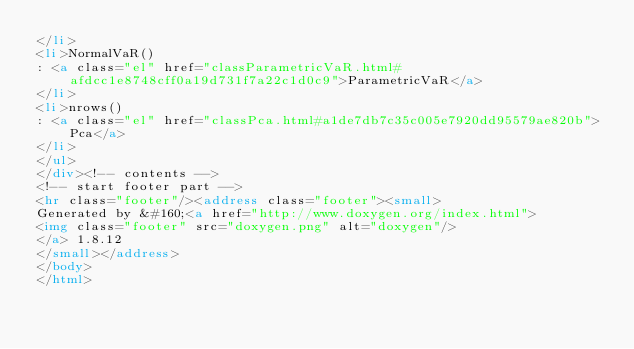<code> <loc_0><loc_0><loc_500><loc_500><_HTML_></li>
<li>NormalVaR()
: <a class="el" href="classParametricVaR.html#afdcc1e8748cff0a19d731f7a22c1d0c9">ParametricVaR</a>
</li>
<li>nrows()
: <a class="el" href="classPca.html#a1de7db7c35c005e7920dd95579ae820b">Pca</a>
</li>
</ul>
</div><!-- contents -->
<!-- start footer part -->
<hr class="footer"/><address class="footer"><small>
Generated by &#160;<a href="http://www.doxygen.org/index.html">
<img class="footer" src="doxygen.png" alt="doxygen"/>
</a> 1.8.12
</small></address>
</body>
</html>
</code> 